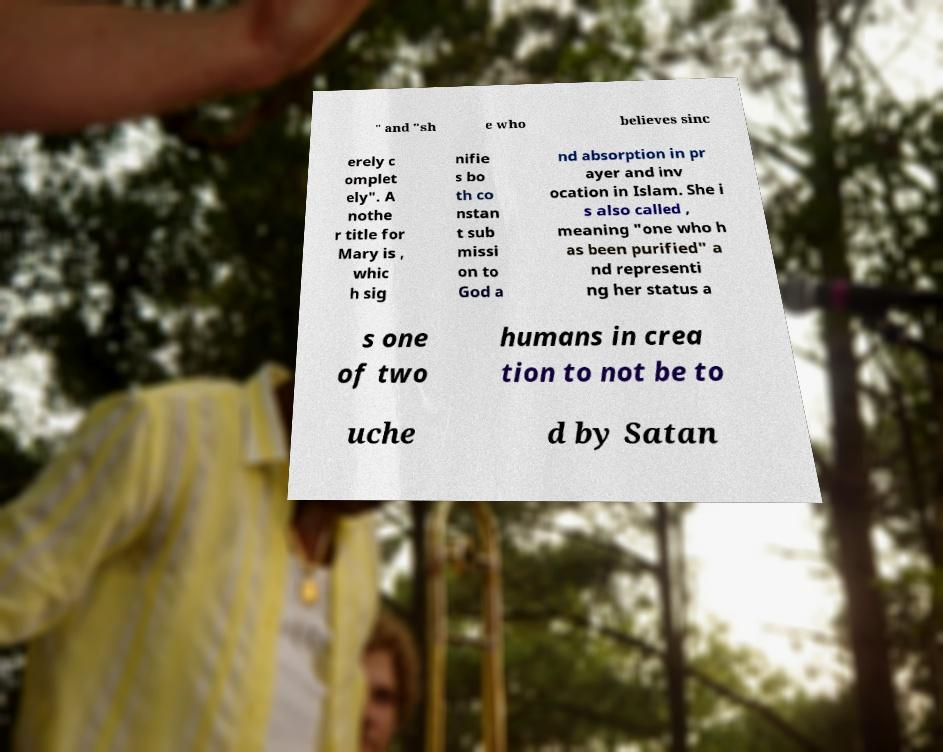Please identify and transcribe the text found in this image. " and "sh e who believes sinc erely c omplet ely". A nothe r title for Mary is , whic h sig nifie s bo th co nstan t sub missi on to God a nd absorption in pr ayer and inv ocation in Islam. She i s also called , meaning "one who h as been purified" a nd representi ng her status a s one of two humans in crea tion to not be to uche d by Satan 